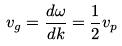Convert formula to latex. <formula><loc_0><loc_0><loc_500><loc_500>v _ { g } = \frac { d \omega } { d k } = \frac { 1 } { 2 } v _ { p }</formula> 